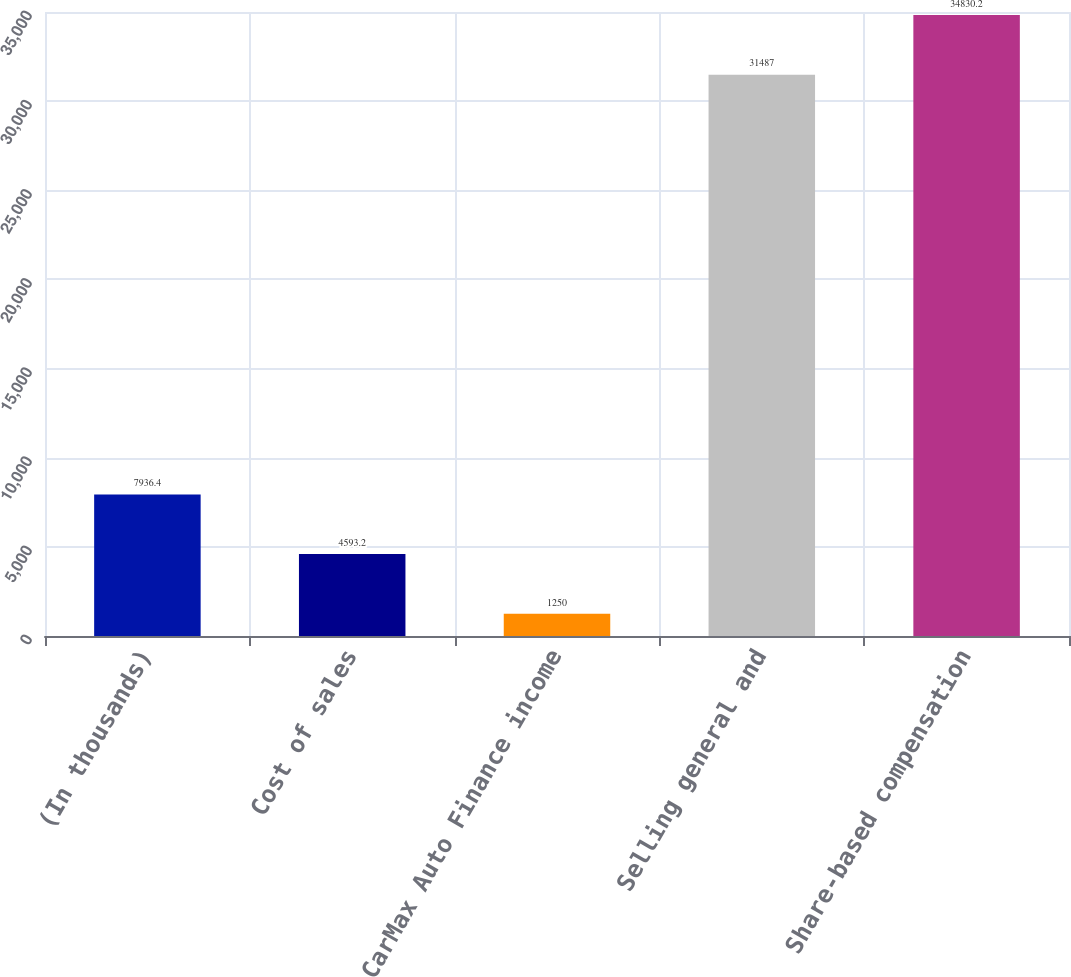<chart> <loc_0><loc_0><loc_500><loc_500><bar_chart><fcel>(In thousands)<fcel>Cost of sales<fcel>CarMax Auto Finance income<fcel>Selling general and<fcel>Share-based compensation<nl><fcel>7936.4<fcel>4593.2<fcel>1250<fcel>31487<fcel>34830.2<nl></chart> 